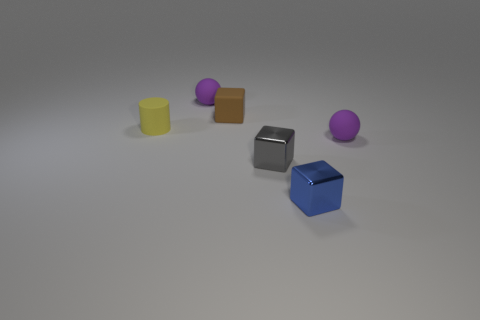Add 2 yellow rubber things. How many objects exist? 8 Subtract all cylinders. How many objects are left? 5 Add 3 metallic things. How many metallic things exist? 5 Subtract 0 red cylinders. How many objects are left? 6 Subtract all yellow matte cylinders. Subtract all tiny gray metal objects. How many objects are left? 4 Add 2 small brown things. How many small brown things are left? 3 